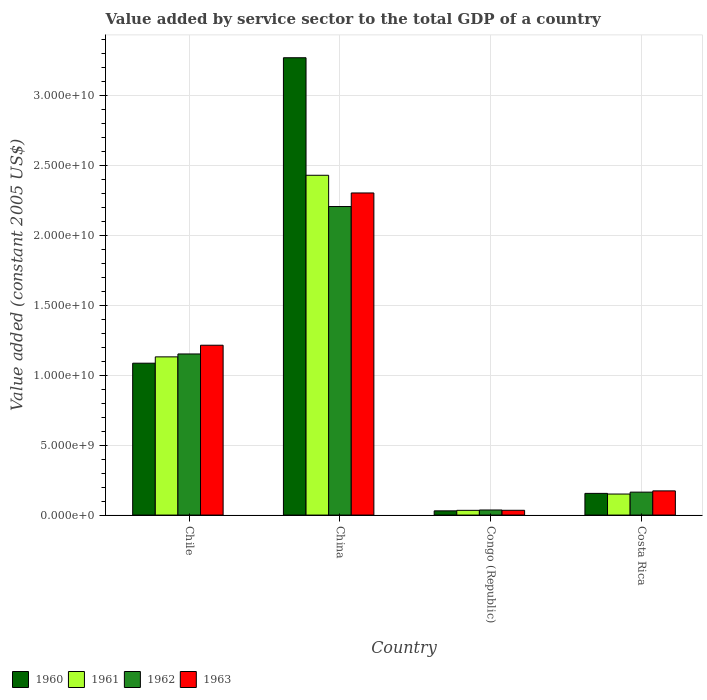How many different coloured bars are there?
Your answer should be compact. 4. Are the number of bars per tick equal to the number of legend labels?
Keep it short and to the point. Yes. Are the number of bars on each tick of the X-axis equal?
Provide a succinct answer. Yes. How many bars are there on the 3rd tick from the left?
Provide a succinct answer. 4. How many bars are there on the 4th tick from the right?
Your answer should be compact. 4. In how many cases, is the number of bars for a given country not equal to the number of legend labels?
Provide a succinct answer. 0. What is the value added by service sector in 1962 in China?
Ensure brevity in your answer.  2.21e+1. Across all countries, what is the maximum value added by service sector in 1963?
Provide a succinct answer. 2.30e+1. Across all countries, what is the minimum value added by service sector in 1962?
Your answer should be very brief. 3.64e+08. In which country was the value added by service sector in 1960 minimum?
Keep it short and to the point. Congo (Republic). What is the total value added by service sector in 1963 in the graph?
Provide a succinct answer. 3.73e+1. What is the difference between the value added by service sector in 1960 in Chile and that in China?
Keep it short and to the point. -2.19e+1. What is the difference between the value added by service sector in 1962 in Costa Rica and the value added by service sector in 1960 in China?
Make the answer very short. -3.11e+1. What is the average value added by service sector in 1961 per country?
Provide a short and direct response. 9.37e+09. What is the difference between the value added by service sector of/in 1960 and value added by service sector of/in 1962 in Congo (Republic)?
Offer a terse response. -6.23e+07. What is the ratio of the value added by service sector in 1962 in Chile to that in Costa Rica?
Provide a short and direct response. 7.02. Is the difference between the value added by service sector in 1960 in Chile and Congo (Republic) greater than the difference between the value added by service sector in 1962 in Chile and Congo (Republic)?
Offer a terse response. No. What is the difference between the highest and the second highest value added by service sector in 1960?
Give a very brief answer. 9.31e+09. What is the difference between the highest and the lowest value added by service sector in 1960?
Keep it short and to the point. 3.24e+1. In how many countries, is the value added by service sector in 1963 greater than the average value added by service sector in 1963 taken over all countries?
Give a very brief answer. 2. Is it the case that in every country, the sum of the value added by service sector in 1963 and value added by service sector in 1962 is greater than the sum of value added by service sector in 1960 and value added by service sector in 1961?
Your answer should be very brief. No. What does the 1st bar from the left in Costa Rica represents?
Provide a short and direct response. 1960. Is it the case that in every country, the sum of the value added by service sector in 1960 and value added by service sector in 1962 is greater than the value added by service sector in 1963?
Ensure brevity in your answer.  Yes. What is the difference between two consecutive major ticks on the Y-axis?
Your answer should be very brief. 5.00e+09. Are the values on the major ticks of Y-axis written in scientific E-notation?
Provide a succinct answer. Yes. Does the graph contain any zero values?
Your answer should be compact. No. How many legend labels are there?
Keep it short and to the point. 4. How are the legend labels stacked?
Ensure brevity in your answer.  Horizontal. What is the title of the graph?
Ensure brevity in your answer.  Value added by service sector to the total GDP of a country. What is the label or title of the Y-axis?
Make the answer very short. Value added (constant 2005 US$). What is the Value added (constant 2005 US$) in 1960 in Chile?
Provide a short and direct response. 1.09e+1. What is the Value added (constant 2005 US$) of 1961 in Chile?
Give a very brief answer. 1.13e+1. What is the Value added (constant 2005 US$) in 1962 in Chile?
Offer a terse response. 1.15e+1. What is the Value added (constant 2005 US$) in 1963 in Chile?
Provide a succinct answer. 1.22e+1. What is the Value added (constant 2005 US$) of 1960 in China?
Ensure brevity in your answer.  3.27e+1. What is the Value added (constant 2005 US$) in 1961 in China?
Ensure brevity in your answer.  2.43e+1. What is the Value added (constant 2005 US$) in 1962 in China?
Your answer should be very brief. 2.21e+1. What is the Value added (constant 2005 US$) in 1963 in China?
Your response must be concise. 2.30e+1. What is the Value added (constant 2005 US$) of 1960 in Congo (Republic)?
Keep it short and to the point. 3.02e+08. What is the Value added (constant 2005 US$) in 1961 in Congo (Republic)?
Offer a terse response. 3.39e+08. What is the Value added (constant 2005 US$) of 1962 in Congo (Republic)?
Your answer should be compact. 3.64e+08. What is the Value added (constant 2005 US$) in 1963 in Congo (Republic)?
Your answer should be very brief. 3.42e+08. What is the Value added (constant 2005 US$) of 1960 in Costa Rica?
Offer a terse response. 1.55e+09. What is the Value added (constant 2005 US$) in 1961 in Costa Rica?
Ensure brevity in your answer.  1.51e+09. What is the Value added (constant 2005 US$) of 1962 in Costa Rica?
Your response must be concise. 1.64e+09. What is the Value added (constant 2005 US$) of 1963 in Costa Rica?
Keep it short and to the point. 1.73e+09. Across all countries, what is the maximum Value added (constant 2005 US$) in 1960?
Provide a succinct answer. 3.27e+1. Across all countries, what is the maximum Value added (constant 2005 US$) in 1961?
Offer a terse response. 2.43e+1. Across all countries, what is the maximum Value added (constant 2005 US$) in 1962?
Provide a short and direct response. 2.21e+1. Across all countries, what is the maximum Value added (constant 2005 US$) of 1963?
Provide a succinct answer. 2.30e+1. Across all countries, what is the minimum Value added (constant 2005 US$) of 1960?
Your response must be concise. 3.02e+08. Across all countries, what is the minimum Value added (constant 2005 US$) in 1961?
Offer a terse response. 3.39e+08. Across all countries, what is the minimum Value added (constant 2005 US$) in 1962?
Offer a very short reply. 3.64e+08. Across all countries, what is the minimum Value added (constant 2005 US$) in 1963?
Keep it short and to the point. 3.42e+08. What is the total Value added (constant 2005 US$) in 1960 in the graph?
Offer a terse response. 4.54e+1. What is the total Value added (constant 2005 US$) of 1961 in the graph?
Provide a short and direct response. 3.75e+1. What is the total Value added (constant 2005 US$) in 1962 in the graph?
Your answer should be very brief. 3.56e+1. What is the total Value added (constant 2005 US$) in 1963 in the graph?
Give a very brief answer. 3.73e+1. What is the difference between the Value added (constant 2005 US$) in 1960 in Chile and that in China?
Your response must be concise. -2.19e+1. What is the difference between the Value added (constant 2005 US$) in 1961 in Chile and that in China?
Keep it short and to the point. -1.30e+1. What is the difference between the Value added (constant 2005 US$) of 1962 in Chile and that in China?
Give a very brief answer. -1.05e+1. What is the difference between the Value added (constant 2005 US$) in 1963 in Chile and that in China?
Your response must be concise. -1.09e+1. What is the difference between the Value added (constant 2005 US$) in 1960 in Chile and that in Congo (Republic)?
Ensure brevity in your answer.  1.06e+1. What is the difference between the Value added (constant 2005 US$) of 1961 in Chile and that in Congo (Republic)?
Give a very brief answer. 1.10e+1. What is the difference between the Value added (constant 2005 US$) in 1962 in Chile and that in Congo (Republic)?
Provide a succinct answer. 1.12e+1. What is the difference between the Value added (constant 2005 US$) in 1963 in Chile and that in Congo (Republic)?
Keep it short and to the point. 1.18e+1. What is the difference between the Value added (constant 2005 US$) in 1960 in Chile and that in Costa Rica?
Make the answer very short. 9.31e+09. What is the difference between the Value added (constant 2005 US$) of 1961 in Chile and that in Costa Rica?
Give a very brief answer. 9.81e+09. What is the difference between the Value added (constant 2005 US$) in 1962 in Chile and that in Costa Rica?
Your response must be concise. 9.89e+09. What is the difference between the Value added (constant 2005 US$) in 1963 in Chile and that in Costa Rica?
Provide a succinct answer. 1.04e+1. What is the difference between the Value added (constant 2005 US$) of 1960 in China and that in Congo (Republic)?
Give a very brief answer. 3.24e+1. What is the difference between the Value added (constant 2005 US$) of 1961 in China and that in Congo (Republic)?
Offer a very short reply. 2.40e+1. What is the difference between the Value added (constant 2005 US$) in 1962 in China and that in Congo (Republic)?
Offer a very short reply. 2.17e+1. What is the difference between the Value added (constant 2005 US$) of 1963 in China and that in Congo (Republic)?
Offer a terse response. 2.27e+1. What is the difference between the Value added (constant 2005 US$) of 1960 in China and that in Costa Rica?
Give a very brief answer. 3.12e+1. What is the difference between the Value added (constant 2005 US$) in 1961 in China and that in Costa Rica?
Offer a very short reply. 2.28e+1. What is the difference between the Value added (constant 2005 US$) of 1962 in China and that in Costa Rica?
Offer a very short reply. 2.04e+1. What is the difference between the Value added (constant 2005 US$) in 1963 in China and that in Costa Rica?
Your answer should be very brief. 2.13e+1. What is the difference between the Value added (constant 2005 US$) in 1960 in Congo (Republic) and that in Costa Rica?
Offer a very short reply. -1.25e+09. What is the difference between the Value added (constant 2005 US$) of 1961 in Congo (Republic) and that in Costa Rica?
Your answer should be very brief. -1.17e+09. What is the difference between the Value added (constant 2005 US$) of 1962 in Congo (Republic) and that in Costa Rica?
Give a very brief answer. -1.28e+09. What is the difference between the Value added (constant 2005 US$) of 1963 in Congo (Republic) and that in Costa Rica?
Provide a short and direct response. -1.39e+09. What is the difference between the Value added (constant 2005 US$) in 1960 in Chile and the Value added (constant 2005 US$) in 1961 in China?
Offer a terse response. -1.34e+1. What is the difference between the Value added (constant 2005 US$) of 1960 in Chile and the Value added (constant 2005 US$) of 1962 in China?
Ensure brevity in your answer.  -1.12e+1. What is the difference between the Value added (constant 2005 US$) in 1960 in Chile and the Value added (constant 2005 US$) in 1963 in China?
Your response must be concise. -1.22e+1. What is the difference between the Value added (constant 2005 US$) of 1961 in Chile and the Value added (constant 2005 US$) of 1962 in China?
Your response must be concise. -1.08e+1. What is the difference between the Value added (constant 2005 US$) in 1961 in Chile and the Value added (constant 2005 US$) in 1963 in China?
Offer a very short reply. -1.17e+1. What is the difference between the Value added (constant 2005 US$) of 1962 in Chile and the Value added (constant 2005 US$) of 1963 in China?
Provide a short and direct response. -1.15e+1. What is the difference between the Value added (constant 2005 US$) of 1960 in Chile and the Value added (constant 2005 US$) of 1961 in Congo (Republic)?
Provide a succinct answer. 1.05e+1. What is the difference between the Value added (constant 2005 US$) of 1960 in Chile and the Value added (constant 2005 US$) of 1962 in Congo (Republic)?
Keep it short and to the point. 1.05e+1. What is the difference between the Value added (constant 2005 US$) in 1960 in Chile and the Value added (constant 2005 US$) in 1963 in Congo (Republic)?
Your answer should be very brief. 1.05e+1. What is the difference between the Value added (constant 2005 US$) in 1961 in Chile and the Value added (constant 2005 US$) in 1962 in Congo (Republic)?
Provide a short and direct response. 1.10e+1. What is the difference between the Value added (constant 2005 US$) of 1961 in Chile and the Value added (constant 2005 US$) of 1963 in Congo (Republic)?
Keep it short and to the point. 1.10e+1. What is the difference between the Value added (constant 2005 US$) of 1962 in Chile and the Value added (constant 2005 US$) of 1963 in Congo (Republic)?
Provide a short and direct response. 1.12e+1. What is the difference between the Value added (constant 2005 US$) of 1960 in Chile and the Value added (constant 2005 US$) of 1961 in Costa Rica?
Make the answer very short. 9.36e+09. What is the difference between the Value added (constant 2005 US$) of 1960 in Chile and the Value added (constant 2005 US$) of 1962 in Costa Rica?
Offer a terse response. 9.23e+09. What is the difference between the Value added (constant 2005 US$) in 1960 in Chile and the Value added (constant 2005 US$) in 1963 in Costa Rica?
Provide a succinct answer. 9.14e+09. What is the difference between the Value added (constant 2005 US$) in 1961 in Chile and the Value added (constant 2005 US$) in 1962 in Costa Rica?
Provide a succinct answer. 9.68e+09. What is the difference between the Value added (constant 2005 US$) of 1961 in Chile and the Value added (constant 2005 US$) of 1963 in Costa Rica?
Your response must be concise. 9.59e+09. What is the difference between the Value added (constant 2005 US$) of 1962 in Chile and the Value added (constant 2005 US$) of 1963 in Costa Rica?
Your answer should be very brief. 9.80e+09. What is the difference between the Value added (constant 2005 US$) in 1960 in China and the Value added (constant 2005 US$) in 1961 in Congo (Republic)?
Provide a short and direct response. 3.24e+1. What is the difference between the Value added (constant 2005 US$) of 1960 in China and the Value added (constant 2005 US$) of 1962 in Congo (Republic)?
Your answer should be compact. 3.24e+1. What is the difference between the Value added (constant 2005 US$) of 1960 in China and the Value added (constant 2005 US$) of 1963 in Congo (Republic)?
Provide a short and direct response. 3.24e+1. What is the difference between the Value added (constant 2005 US$) of 1961 in China and the Value added (constant 2005 US$) of 1962 in Congo (Republic)?
Your answer should be compact. 2.39e+1. What is the difference between the Value added (constant 2005 US$) of 1961 in China and the Value added (constant 2005 US$) of 1963 in Congo (Republic)?
Keep it short and to the point. 2.40e+1. What is the difference between the Value added (constant 2005 US$) of 1962 in China and the Value added (constant 2005 US$) of 1963 in Congo (Republic)?
Your answer should be compact. 2.17e+1. What is the difference between the Value added (constant 2005 US$) in 1960 in China and the Value added (constant 2005 US$) in 1961 in Costa Rica?
Your response must be concise. 3.12e+1. What is the difference between the Value added (constant 2005 US$) in 1960 in China and the Value added (constant 2005 US$) in 1962 in Costa Rica?
Your answer should be very brief. 3.11e+1. What is the difference between the Value added (constant 2005 US$) in 1960 in China and the Value added (constant 2005 US$) in 1963 in Costa Rica?
Make the answer very short. 3.10e+1. What is the difference between the Value added (constant 2005 US$) in 1961 in China and the Value added (constant 2005 US$) in 1962 in Costa Rica?
Offer a terse response. 2.27e+1. What is the difference between the Value added (constant 2005 US$) in 1961 in China and the Value added (constant 2005 US$) in 1963 in Costa Rica?
Your answer should be compact. 2.26e+1. What is the difference between the Value added (constant 2005 US$) in 1962 in China and the Value added (constant 2005 US$) in 1963 in Costa Rica?
Provide a succinct answer. 2.03e+1. What is the difference between the Value added (constant 2005 US$) of 1960 in Congo (Republic) and the Value added (constant 2005 US$) of 1961 in Costa Rica?
Your answer should be very brief. -1.20e+09. What is the difference between the Value added (constant 2005 US$) in 1960 in Congo (Republic) and the Value added (constant 2005 US$) in 1962 in Costa Rica?
Offer a very short reply. -1.34e+09. What is the difference between the Value added (constant 2005 US$) in 1960 in Congo (Republic) and the Value added (constant 2005 US$) in 1963 in Costa Rica?
Keep it short and to the point. -1.43e+09. What is the difference between the Value added (constant 2005 US$) in 1961 in Congo (Republic) and the Value added (constant 2005 US$) in 1962 in Costa Rica?
Your answer should be compact. -1.30e+09. What is the difference between the Value added (constant 2005 US$) of 1961 in Congo (Republic) and the Value added (constant 2005 US$) of 1963 in Costa Rica?
Ensure brevity in your answer.  -1.39e+09. What is the difference between the Value added (constant 2005 US$) of 1962 in Congo (Republic) and the Value added (constant 2005 US$) of 1963 in Costa Rica?
Your response must be concise. -1.37e+09. What is the average Value added (constant 2005 US$) of 1960 per country?
Your answer should be compact. 1.14e+1. What is the average Value added (constant 2005 US$) in 1961 per country?
Keep it short and to the point. 9.37e+09. What is the average Value added (constant 2005 US$) in 1962 per country?
Your answer should be very brief. 8.90e+09. What is the average Value added (constant 2005 US$) of 1963 per country?
Provide a short and direct response. 9.32e+09. What is the difference between the Value added (constant 2005 US$) of 1960 and Value added (constant 2005 US$) of 1961 in Chile?
Provide a short and direct response. -4.53e+08. What is the difference between the Value added (constant 2005 US$) of 1960 and Value added (constant 2005 US$) of 1962 in Chile?
Offer a very short reply. -6.60e+08. What is the difference between the Value added (constant 2005 US$) in 1960 and Value added (constant 2005 US$) in 1963 in Chile?
Your response must be concise. -1.29e+09. What is the difference between the Value added (constant 2005 US$) of 1961 and Value added (constant 2005 US$) of 1962 in Chile?
Ensure brevity in your answer.  -2.07e+08. What is the difference between the Value added (constant 2005 US$) of 1961 and Value added (constant 2005 US$) of 1963 in Chile?
Make the answer very short. -8.32e+08. What is the difference between the Value added (constant 2005 US$) in 1962 and Value added (constant 2005 US$) in 1963 in Chile?
Provide a short and direct response. -6.25e+08. What is the difference between the Value added (constant 2005 US$) of 1960 and Value added (constant 2005 US$) of 1961 in China?
Provide a short and direct response. 8.41e+09. What is the difference between the Value added (constant 2005 US$) in 1960 and Value added (constant 2005 US$) in 1962 in China?
Give a very brief answer. 1.06e+1. What is the difference between the Value added (constant 2005 US$) in 1960 and Value added (constant 2005 US$) in 1963 in China?
Make the answer very short. 9.68e+09. What is the difference between the Value added (constant 2005 US$) of 1961 and Value added (constant 2005 US$) of 1962 in China?
Your response must be concise. 2.24e+09. What is the difference between the Value added (constant 2005 US$) in 1961 and Value added (constant 2005 US$) in 1963 in China?
Offer a very short reply. 1.27e+09. What is the difference between the Value added (constant 2005 US$) of 1962 and Value added (constant 2005 US$) of 1963 in China?
Provide a short and direct response. -9.71e+08. What is the difference between the Value added (constant 2005 US$) in 1960 and Value added (constant 2005 US$) in 1961 in Congo (Republic)?
Provide a succinct answer. -3.74e+07. What is the difference between the Value added (constant 2005 US$) of 1960 and Value added (constant 2005 US$) of 1962 in Congo (Republic)?
Your response must be concise. -6.23e+07. What is the difference between the Value added (constant 2005 US$) of 1960 and Value added (constant 2005 US$) of 1963 in Congo (Republic)?
Offer a very short reply. -4.05e+07. What is the difference between the Value added (constant 2005 US$) in 1961 and Value added (constant 2005 US$) in 1962 in Congo (Republic)?
Your answer should be compact. -2.49e+07. What is the difference between the Value added (constant 2005 US$) of 1961 and Value added (constant 2005 US$) of 1963 in Congo (Republic)?
Your answer should be very brief. -3.09e+06. What is the difference between the Value added (constant 2005 US$) of 1962 and Value added (constant 2005 US$) of 1963 in Congo (Republic)?
Make the answer very short. 2.18e+07. What is the difference between the Value added (constant 2005 US$) in 1960 and Value added (constant 2005 US$) in 1961 in Costa Rica?
Your response must be concise. 4.72e+07. What is the difference between the Value added (constant 2005 US$) in 1960 and Value added (constant 2005 US$) in 1962 in Costa Rica?
Provide a short and direct response. -8.87e+07. What is the difference between the Value added (constant 2005 US$) in 1960 and Value added (constant 2005 US$) in 1963 in Costa Rica?
Provide a succinct answer. -1.78e+08. What is the difference between the Value added (constant 2005 US$) in 1961 and Value added (constant 2005 US$) in 1962 in Costa Rica?
Make the answer very short. -1.36e+08. What is the difference between the Value added (constant 2005 US$) of 1961 and Value added (constant 2005 US$) of 1963 in Costa Rica?
Offer a terse response. -2.25e+08. What is the difference between the Value added (constant 2005 US$) of 1962 and Value added (constant 2005 US$) of 1963 in Costa Rica?
Your response must be concise. -8.94e+07. What is the ratio of the Value added (constant 2005 US$) of 1960 in Chile to that in China?
Give a very brief answer. 0.33. What is the ratio of the Value added (constant 2005 US$) in 1961 in Chile to that in China?
Offer a very short reply. 0.47. What is the ratio of the Value added (constant 2005 US$) of 1962 in Chile to that in China?
Offer a very short reply. 0.52. What is the ratio of the Value added (constant 2005 US$) of 1963 in Chile to that in China?
Keep it short and to the point. 0.53. What is the ratio of the Value added (constant 2005 US$) of 1960 in Chile to that in Congo (Republic)?
Your answer should be very brief. 36.04. What is the ratio of the Value added (constant 2005 US$) of 1961 in Chile to that in Congo (Republic)?
Your answer should be compact. 33.4. What is the ratio of the Value added (constant 2005 US$) in 1962 in Chile to that in Congo (Republic)?
Offer a terse response. 31.68. What is the ratio of the Value added (constant 2005 US$) in 1963 in Chile to that in Congo (Republic)?
Ensure brevity in your answer.  35.53. What is the ratio of the Value added (constant 2005 US$) in 1960 in Chile to that in Costa Rica?
Provide a short and direct response. 7. What is the ratio of the Value added (constant 2005 US$) of 1961 in Chile to that in Costa Rica?
Provide a succinct answer. 7.52. What is the ratio of the Value added (constant 2005 US$) of 1962 in Chile to that in Costa Rica?
Provide a short and direct response. 7.02. What is the ratio of the Value added (constant 2005 US$) of 1963 in Chile to that in Costa Rica?
Offer a very short reply. 7.02. What is the ratio of the Value added (constant 2005 US$) of 1960 in China to that in Congo (Republic)?
Give a very brief answer. 108.51. What is the ratio of the Value added (constant 2005 US$) in 1961 in China to that in Congo (Republic)?
Your response must be concise. 71.73. What is the ratio of the Value added (constant 2005 US$) of 1962 in China to that in Congo (Republic)?
Make the answer very short. 60.67. What is the ratio of the Value added (constant 2005 US$) in 1963 in China to that in Congo (Republic)?
Keep it short and to the point. 67.39. What is the ratio of the Value added (constant 2005 US$) in 1960 in China to that in Costa Rica?
Give a very brief answer. 21.08. What is the ratio of the Value added (constant 2005 US$) of 1961 in China to that in Costa Rica?
Offer a very short reply. 16.15. What is the ratio of the Value added (constant 2005 US$) in 1962 in China to that in Costa Rica?
Offer a terse response. 13.45. What is the ratio of the Value added (constant 2005 US$) of 1963 in China to that in Costa Rica?
Provide a short and direct response. 13.32. What is the ratio of the Value added (constant 2005 US$) of 1960 in Congo (Republic) to that in Costa Rica?
Give a very brief answer. 0.19. What is the ratio of the Value added (constant 2005 US$) in 1961 in Congo (Republic) to that in Costa Rica?
Provide a short and direct response. 0.23. What is the ratio of the Value added (constant 2005 US$) of 1962 in Congo (Republic) to that in Costa Rica?
Provide a short and direct response. 0.22. What is the ratio of the Value added (constant 2005 US$) in 1963 in Congo (Republic) to that in Costa Rica?
Your answer should be compact. 0.2. What is the difference between the highest and the second highest Value added (constant 2005 US$) in 1960?
Provide a short and direct response. 2.19e+1. What is the difference between the highest and the second highest Value added (constant 2005 US$) of 1961?
Make the answer very short. 1.30e+1. What is the difference between the highest and the second highest Value added (constant 2005 US$) in 1962?
Make the answer very short. 1.05e+1. What is the difference between the highest and the second highest Value added (constant 2005 US$) in 1963?
Provide a short and direct response. 1.09e+1. What is the difference between the highest and the lowest Value added (constant 2005 US$) in 1960?
Offer a terse response. 3.24e+1. What is the difference between the highest and the lowest Value added (constant 2005 US$) of 1961?
Ensure brevity in your answer.  2.40e+1. What is the difference between the highest and the lowest Value added (constant 2005 US$) of 1962?
Your response must be concise. 2.17e+1. What is the difference between the highest and the lowest Value added (constant 2005 US$) in 1963?
Provide a short and direct response. 2.27e+1. 